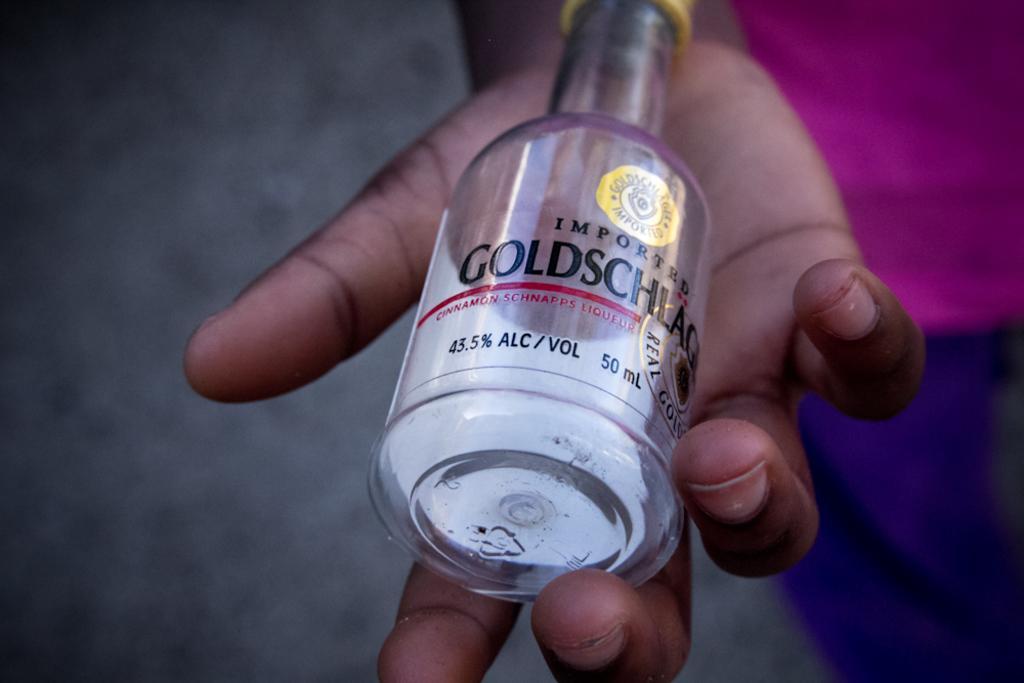Describe this image in one or two sentences. In this image I can see a bottle and a brand name is written on it. And this bottle is holding a person with hand. The person is wearing the pink and violet color dress. 